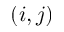<formula> <loc_0><loc_0><loc_500><loc_500>( i , j )</formula> 